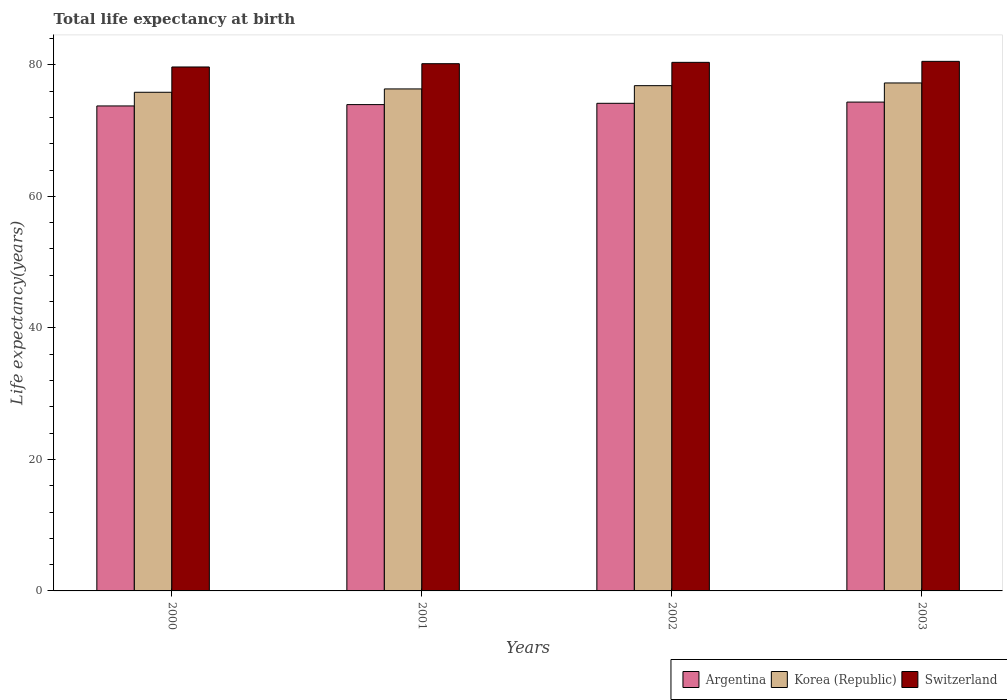How many groups of bars are there?
Your answer should be compact. 4. How many bars are there on the 4th tick from the left?
Provide a short and direct response. 3. What is the label of the 1st group of bars from the left?
Make the answer very short. 2000. What is the life expectancy at birth in in Switzerland in 2002?
Your response must be concise. 80.39. Across all years, what is the maximum life expectancy at birth in in Korea (Republic)?
Give a very brief answer. 77.25. Across all years, what is the minimum life expectancy at birth in in Argentina?
Provide a short and direct response. 73.76. In which year was the life expectancy at birth in in Switzerland maximum?
Offer a very short reply. 2003. In which year was the life expectancy at birth in in Argentina minimum?
Provide a short and direct response. 2000. What is the total life expectancy at birth in in Korea (Republic) in the graph?
Offer a terse response. 306.27. What is the difference between the life expectancy at birth in in Argentina in 2001 and that in 2002?
Make the answer very short. -0.2. What is the difference between the life expectancy at birth in in Argentina in 2001 and the life expectancy at birth in in Korea (Republic) in 2002?
Offer a very short reply. -2.88. What is the average life expectancy at birth in in Argentina per year?
Ensure brevity in your answer.  74.05. In the year 2001, what is the difference between the life expectancy at birth in in Switzerland and life expectancy at birth in in Argentina?
Keep it short and to the point. 6.22. In how many years, is the life expectancy at birth in in Argentina greater than 68 years?
Keep it short and to the point. 4. What is the ratio of the life expectancy at birth in in Korea (Republic) in 2000 to that in 2003?
Provide a short and direct response. 0.98. What is the difference between the highest and the second highest life expectancy at birth in in Argentina?
Provide a succinct answer. 0.19. What is the difference between the highest and the lowest life expectancy at birth in in Korea (Republic)?
Give a very brief answer. 1.41. In how many years, is the life expectancy at birth in in Switzerland greater than the average life expectancy at birth in in Switzerland taken over all years?
Offer a very short reply. 2. Is the sum of the life expectancy at birth in in Korea (Republic) in 2000 and 2003 greater than the maximum life expectancy at birth in in Switzerland across all years?
Ensure brevity in your answer.  Yes. What does the 1st bar from the left in 2003 represents?
Offer a terse response. Argentina. How many bars are there?
Ensure brevity in your answer.  12. How many years are there in the graph?
Your answer should be very brief. 4. What is the difference between two consecutive major ticks on the Y-axis?
Provide a short and direct response. 20. How many legend labels are there?
Give a very brief answer. 3. How are the legend labels stacked?
Your response must be concise. Horizontal. What is the title of the graph?
Provide a succinct answer. Total life expectancy at birth. What is the label or title of the X-axis?
Provide a succinct answer. Years. What is the label or title of the Y-axis?
Your answer should be very brief. Life expectancy(years). What is the Life expectancy(years) in Argentina in 2000?
Ensure brevity in your answer.  73.76. What is the Life expectancy(years) of Korea (Republic) in 2000?
Your answer should be very brief. 75.84. What is the Life expectancy(years) in Switzerland in 2000?
Your response must be concise. 79.68. What is the Life expectancy(years) of Argentina in 2001?
Your answer should be compact. 73.96. What is the Life expectancy(years) in Korea (Republic) in 2001?
Your answer should be very brief. 76.34. What is the Life expectancy(years) in Switzerland in 2001?
Offer a terse response. 80.18. What is the Life expectancy(years) in Argentina in 2002?
Give a very brief answer. 74.16. What is the Life expectancy(years) in Korea (Republic) in 2002?
Offer a very short reply. 76.84. What is the Life expectancy(years) of Switzerland in 2002?
Offer a terse response. 80.39. What is the Life expectancy(years) in Argentina in 2003?
Keep it short and to the point. 74.34. What is the Life expectancy(years) in Korea (Republic) in 2003?
Provide a short and direct response. 77.25. What is the Life expectancy(years) in Switzerland in 2003?
Your response must be concise. 80.54. Across all years, what is the maximum Life expectancy(years) in Argentina?
Make the answer very short. 74.34. Across all years, what is the maximum Life expectancy(years) of Korea (Republic)?
Offer a terse response. 77.25. Across all years, what is the maximum Life expectancy(years) of Switzerland?
Your answer should be very brief. 80.54. Across all years, what is the minimum Life expectancy(years) in Argentina?
Your answer should be very brief. 73.76. Across all years, what is the minimum Life expectancy(years) in Korea (Republic)?
Ensure brevity in your answer.  75.84. Across all years, what is the minimum Life expectancy(years) in Switzerland?
Ensure brevity in your answer.  79.68. What is the total Life expectancy(years) in Argentina in the graph?
Provide a short and direct response. 296.21. What is the total Life expectancy(years) of Korea (Republic) in the graph?
Give a very brief answer. 306.27. What is the total Life expectancy(years) in Switzerland in the graph?
Your response must be concise. 320.78. What is the difference between the Life expectancy(years) in Argentina in 2000 and that in 2001?
Offer a very short reply. -0.2. What is the difference between the Life expectancy(years) of Korea (Republic) in 2000 and that in 2001?
Ensure brevity in your answer.  -0.51. What is the difference between the Life expectancy(years) of Argentina in 2000 and that in 2002?
Offer a very short reply. -0.4. What is the difference between the Life expectancy(years) of Korea (Republic) in 2000 and that in 2002?
Make the answer very short. -1. What is the difference between the Life expectancy(years) in Switzerland in 2000 and that in 2002?
Provide a short and direct response. -0.7. What is the difference between the Life expectancy(years) of Argentina in 2000 and that in 2003?
Offer a terse response. -0.59. What is the difference between the Life expectancy(years) of Korea (Republic) in 2000 and that in 2003?
Your response must be concise. -1.41. What is the difference between the Life expectancy(years) of Switzerland in 2000 and that in 2003?
Offer a terse response. -0.86. What is the difference between the Life expectancy(years) of Argentina in 2001 and that in 2002?
Make the answer very short. -0.2. What is the difference between the Life expectancy(years) in Korea (Republic) in 2001 and that in 2002?
Ensure brevity in your answer.  -0.5. What is the difference between the Life expectancy(years) of Switzerland in 2001 and that in 2002?
Provide a short and direct response. -0.2. What is the difference between the Life expectancy(years) in Argentina in 2001 and that in 2003?
Your response must be concise. -0.38. What is the difference between the Life expectancy(years) of Korea (Republic) in 2001 and that in 2003?
Offer a very short reply. -0.91. What is the difference between the Life expectancy(years) in Switzerland in 2001 and that in 2003?
Provide a short and direct response. -0.36. What is the difference between the Life expectancy(years) in Argentina in 2002 and that in 2003?
Offer a very short reply. -0.19. What is the difference between the Life expectancy(years) of Korea (Republic) in 2002 and that in 2003?
Give a very brief answer. -0.41. What is the difference between the Life expectancy(years) of Switzerland in 2002 and that in 2003?
Ensure brevity in your answer.  -0.15. What is the difference between the Life expectancy(years) in Argentina in 2000 and the Life expectancy(years) in Korea (Republic) in 2001?
Make the answer very short. -2.59. What is the difference between the Life expectancy(years) of Argentina in 2000 and the Life expectancy(years) of Switzerland in 2001?
Your answer should be compact. -6.42. What is the difference between the Life expectancy(years) in Korea (Republic) in 2000 and the Life expectancy(years) in Switzerland in 2001?
Keep it short and to the point. -4.35. What is the difference between the Life expectancy(years) of Argentina in 2000 and the Life expectancy(years) of Korea (Republic) in 2002?
Your response must be concise. -3.08. What is the difference between the Life expectancy(years) of Argentina in 2000 and the Life expectancy(years) of Switzerland in 2002?
Offer a terse response. -6.63. What is the difference between the Life expectancy(years) in Korea (Republic) in 2000 and the Life expectancy(years) in Switzerland in 2002?
Offer a very short reply. -4.55. What is the difference between the Life expectancy(years) in Argentina in 2000 and the Life expectancy(years) in Korea (Republic) in 2003?
Offer a very short reply. -3.49. What is the difference between the Life expectancy(years) of Argentina in 2000 and the Life expectancy(years) of Switzerland in 2003?
Ensure brevity in your answer.  -6.78. What is the difference between the Life expectancy(years) of Korea (Republic) in 2000 and the Life expectancy(years) of Switzerland in 2003?
Your answer should be compact. -4.7. What is the difference between the Life expectancy(years) of Argentina in 2001 and the Life expectancy(years) of Korea (Republic) in 2002?
Your response must be concise. -2.88. What is the difference between the Life expectancy(years) in Argentina in 2001 and the Life expectancy(years) in Switzerland in 2002?
Your response must be concise. -6.42. What is the difference between the Life expectancy(years) in Korea (Republic) in 2001 and the Life expectancy(years) in Switzerland in 2002?
Your response must be concise. -4.04. What is the difference between the Life expectancy(years) of Argentina in 2001 and the Life expectancy(years) of Korea (Republic) in 2003?
Your response must be concise. -3.29. What is the difference between the Life expectancy(years) of Argentina in 2001 and the Life expectancy(years) of Switzerland in 2003?
Keep it short and to the point. -6.58. What is the difference between the Life expectancy(years) of Korea (Republic) in 2001 and the Life expectancy(years) of Switzerland in 2003?
Provide a short and direct response. -4.19. What is the difference between the Life expectancy(years) in Argentina in 2002 and the Life expectancy(years) in Korea (Republic) in 2003?
Your answer should be compact. -3.09. What is the difference between the Life expectancy(years) of Argentina in 2002 and the Life expectancy(years) of Switzerland in 2003?
Offer a terse response. -6.38. What is the difference between the Life expectancy(years) in Korea (Republic) in 2002 and the Life expectancy(years) in Switzerland in 2003?
Keep it short and to the point. -3.7. What is the average Life expectancy(years) in Argentina per year?
Ensure brevity in your answer.  74.05. What is the average Life expectancy(years) in Korea (Republic) per year?
Ensure brevity in your answer.  76.57. What is the average Life expectancy(years) of Switzerland per year?
Give a very brief answer. 80.2. In the year 2000, what is the difference between the Life expectancy(years) of Argentina and Life expectancy(years) of Korea (Republic)?
Ensure brevity in your answer.  -2.08. In the year 2000, what is the difference between the Life expectancy(years) in Argentina and Life expectancy(years) in Switzerland?
Offer a very short reply. -5.92. In the year 2000, what is the difference between the Life expectancy(years) of Korea (Republic) and Life expectancy(years) of Switzerland?
Provide a short and direct response. -3.85. In the year 2001, what is the difference between the Life expectancy(years) of Argentina and Life expectancy(years) of Korea (Republic)?
Your response must be concise. -2.38. In the year 2001, what is the difference between the Life expectancy(years) in Argentina and Life expectancy(years) in Switzerland?
Offer a terse response. -6.22. In the year 2001, what is the difference between the Life expectancy(years) in Korea (Republic) and Life expectancy(years) in Switzerland?
Provide a short and direct response. -3.84. In the year 2002, what is the difference between the Life expectancy(years) of Argentina and Life expectancy(years) of Korea (Republic)?
Provide a short and direct response. -2.68. In the year 2002, what is the difference between the Life expectancy(years) of Argentina and Life expectancy(years) of Switzerland?
Provide a succinct answer. -6.23. In the year 2002, what is the difference between the Life expectancy(years) of Korea (Republic) and Life expectancy(years) of Switzerland?
Offer a terse response. -3.55. In the year 2003, what is the difference between the Life expectancy(years) in Argentina and Life expectancy(years) in Korea (Republic)?
Make the answer very short. -2.91. In the year 2003, what is the difference between the Life expectancy(years) in Argentina and Life expectancy(years) in Switzerland?
Ensure brevity in your answer.  -6.2. In the year 2003, what is the difference between the Life expectancy(years) in Korea (Republic) and Life expectancy(years) in Switzerland?
Make the answer very short. -3.29. What is the ratio of the Life expectancy(years) of Korea (Republic) in 2000 to that in 2002?
Provide a succinct answer. 0.99. What is the ratio of the Life expectancy(years) of Korea (Republic) in 2000 to that in 2003?
Provide a succinct answer. 0.98. What is the ratio of the Life expectancy(years) of Switzerland in 2000 to that in 2003?
Your response must be concise. 0.99. What is the ratio of the Life expectancy(years) in Argentina in 2001 to that in 2002?
Provide a short and direct response. 1. What is the ratio of the Life expectancy(years) of Korea (Republic) in 2001 to that in 2002?
Provide a short and direct response. 0.99. What is the ratio of the Life expectancy(years) in Korea (Republic) in 2001 to that in 2003?
Make the answer very short. 0.99. What is the ratio of the Life expectancy(years) of Switzerland in 2001 to that in 2003?
Your answer should be compact. 1. What is the ratio of the Life expectancy(years) in Argentina in 2002 to that in 2003?
Your response must be concise. 1. What is the ratio of the Life expectancy(years) in Korea (Republic) in 2002 to that in 2003?
Offer a terse response. 0.99. What is the difference between the highest and the second highest Life expectancy(years) in Argentina?
Provide a short and direct response. 0.19. What is the difference between the highest and the second highest Life expectancy(years) of Korea (Republic)?
Provide a short and direct response. 0.41. What is the difference between the highest and the second highest Life expectancy(years) in Switzerland?
Provide a succinct answer. 0.15. What is the difference between the highest and the lowest Life expectancy(years) of Argentina?
Give a very brief answer. 0.59. What is the difference between the highest and the lowest Life expectancy(years) of Korea (Republic)?
Make the answer very short. 1.41. What is the difference between the highest and the lowest Life expectancy(years) in Switzerland?
Your answer should be very brief. 0.86. 